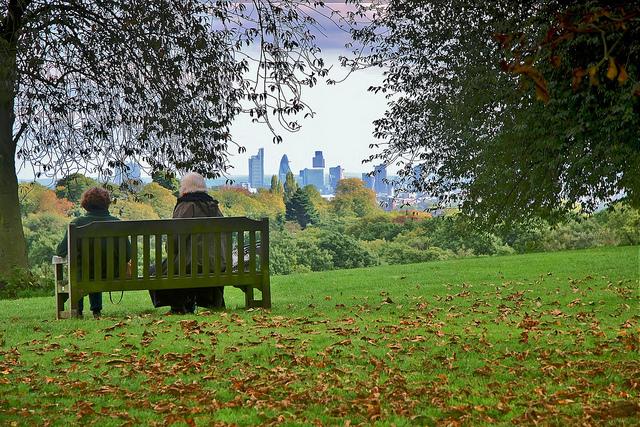How many people are sitting on the bench?
Short answer required. 2. Is this in the countryside?
Concise answer only. Yes. What season does it appear to be?
Keep it brief. Fall. Are the two people sitting on the ground or on a bench?
Answer briefly. Bench. What holiday was this picture taken around?
Concise answer only. Thanksgiving. Who is on the bench?
Give a very brief answer. 2 people. What color is the park bench?
Be succinct. Green. Is the bench for looking at a building?
Be succinct. No. 